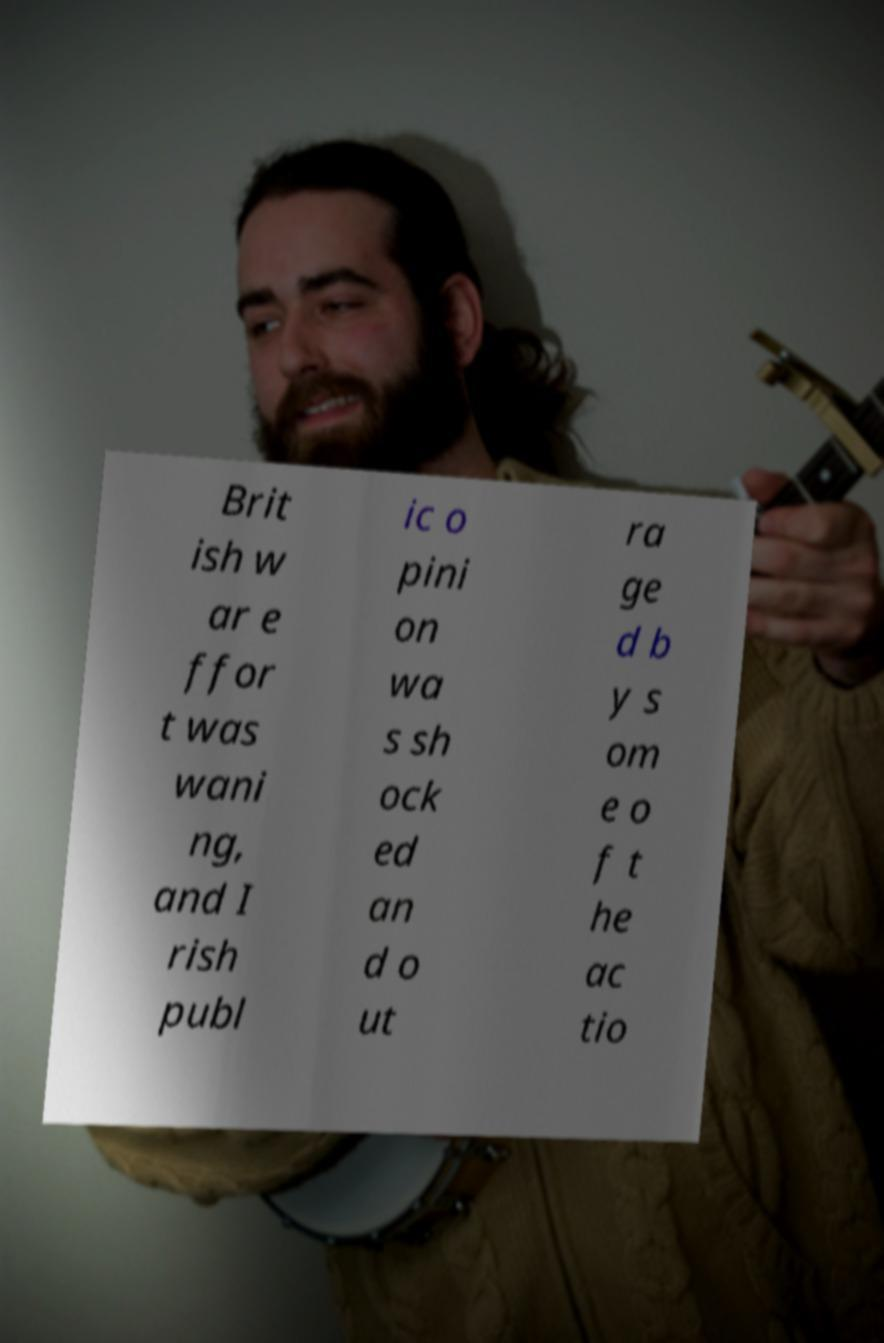Could you assist in decoding the text presented in this image and type it out clearly? Brit ish w ar e ffor t was wani ng, and I rish publ ic o pini on wa s sh ock ed an d o ut ra ge d b y s om e o f t he ac tio 